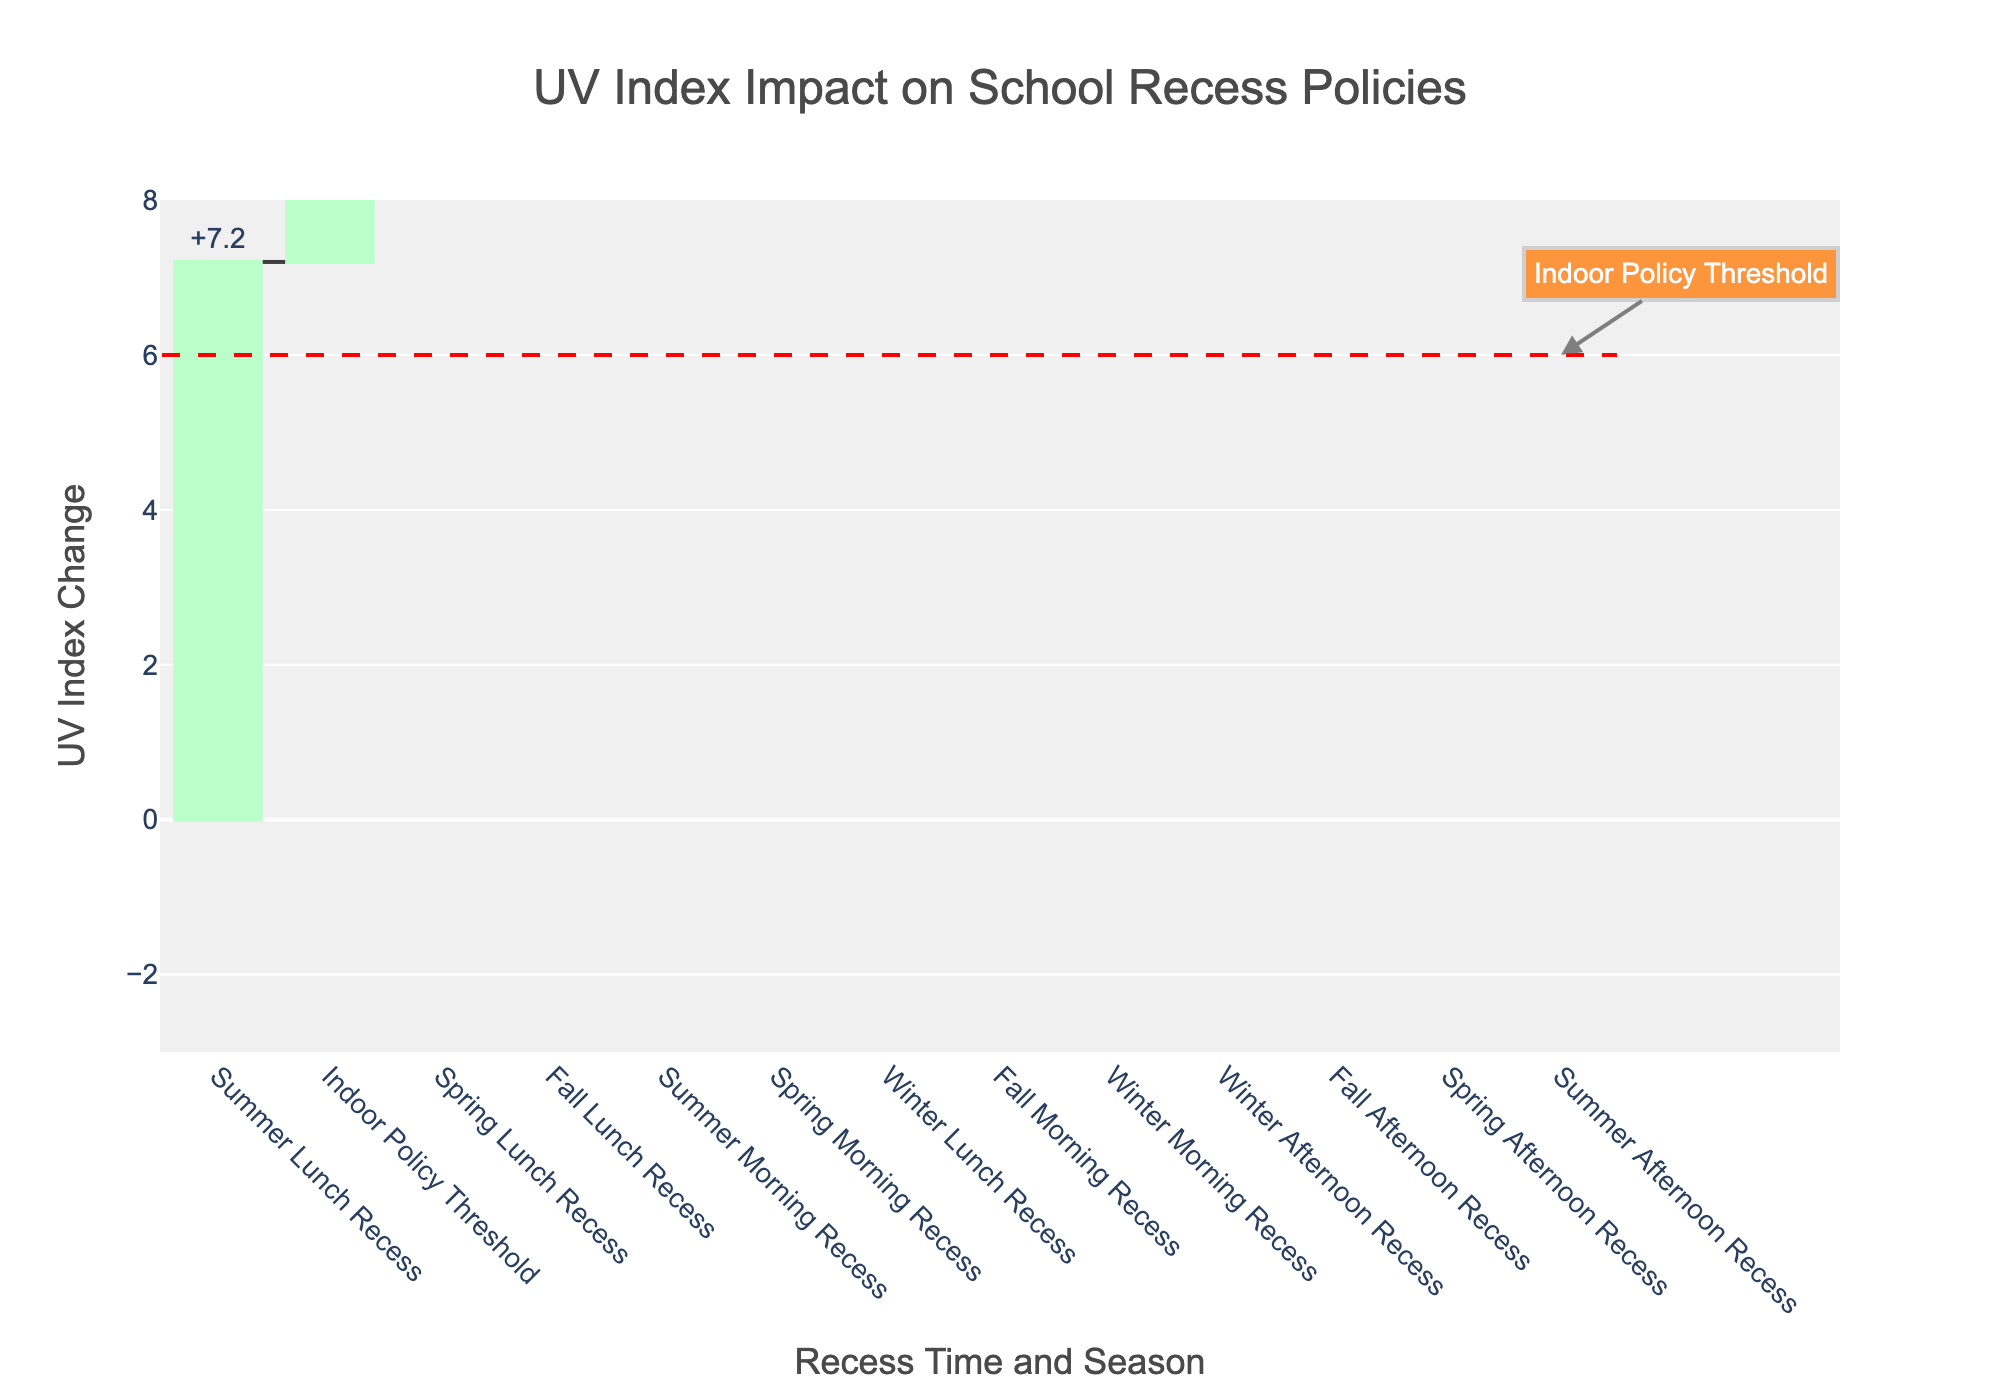What is the highest UV index change among all recess times and seasons? The highest UV index change is for "Summer Lunch Recess", indicated by the longest vertical bar in the chart reaching 7.2.
Answer: Summer Lunch Recess Does any UV index change cross the Indoor Policy Threshold line? Yes, "Summer Lunch Recess" crosses the Indoor Policy Threshold line, showing a UV index change above the threshold of 6.0.
Answer: Yes How does the UV index change during "Spring Afternoon Recess"? The UV index change during "Spring Afternoon Recess" is indicated by the vertical bar dropping below the baseline, showing a value of -1.2.
Answer: -1.2 Which time of day in summer shows the lowest UV index change, and what is the change? The lowest UV index change in summer is during "Summer Afternoon Recess" with a value of -2.5, shown by the negative bar.
Answer: Summer Afternoon Recess, -2.5 Which season has the most positive average UV index change across all recess times? To find the season with the most positive average UV index change, we calculate the average for each season:
Spring: (2.5 + 4.8 - 1.2) / 3 = 2.033
Summer: (3.7 + 7.2 - 2.5) / 3 = 2.8
Fall: (1.8 + 3.9 - 0.9) / 3 = 1.6
Winter: (0.6 + 2.1 - 0.4) / 3 = 0.766
Summer has the most positive average UV index change.
Answer: Summer How does "Fall Afternoon Recess" UV index change compare to "Winter Morning Recess"? "Fall Afternoon Recess" has a UV index change of -0.9, while "Winter Morning Recess" has a UV index change of 0.6. "Winter Morning Recess" is higher.
Answer: Winter Morning Recess is higher What can you infer about the UV index during lunch recess across different seasons? During lunch recess, the UV index changes are the highest compared to other times in each season, as all lunch recess bars (Spring Lunch Recess: 4.8, Summer Lunch Recess: 7.2, Fall Lunch Recess: 3.9, Winter Lunch Recess: 2.1) are closer to or exceed the Indoor Policy Threshold compared to other times in their respective seasons.
Answer: UV index is consistently higher What is the difference in UV index change between "Spring Lunch Recess" and "Winter Morning Recess"? The UV index change for "Spring Lunch Recess" is 4.8, and for "Winter Morning Recess" is 0.6. The difference is 4.8 - 0.6 = 4.2.
Answer: 4.2 During which season are UV index changes for "Afternoon Recess" consistently negative? During both Spring and Fall, the UV index changes for "Afternoon Recess" are negative, shown by the vertical bars below the baseline for "Spring Afternoon Recess" (-1.2) and "Fall Afternoon Recess" (-0.9).
Answer: Spring and Fall 